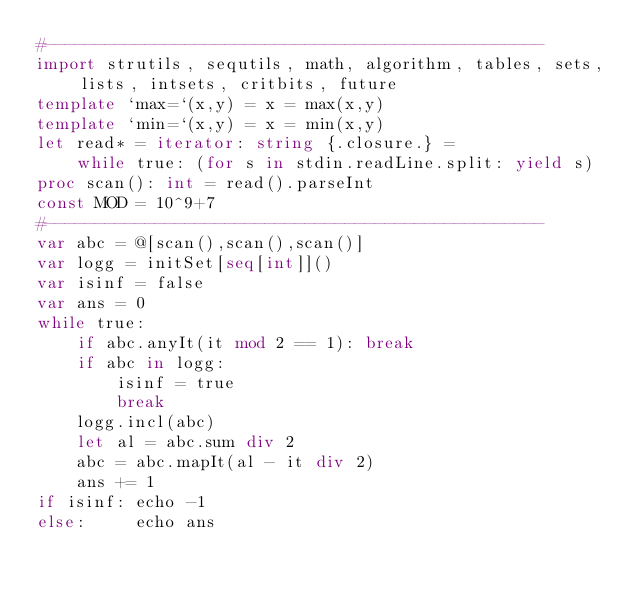Convert code to text. <code><loc_0><loc_0><loc_500><loc_500><_Nim_>#--------------------------------------------------
import strutils, sequtils, math, algorithm, tables, sets, lists, intsets, critbits, future
template `max=`(x,y) = x = max(x,y)
template `min=`(x,y) = x = min(x,y)
let read* = iterator: string {.closure.} =
    while true: (for s in stdin.readLine.split: yield s)
proc scan(): int = read().parseInt
const MOD = 10^9+7
#--------------------------------------------------
var abc = @[scan(),scan(),scan()]
var logg = initSet[seq[int]]()
var isinf = false
var ans = 0
while true:
    if abc.anyIt(it mod 2 == 1): break
    if abc in logg:
        isinf = true
        break
    logg.incl(abc)
    let al = abc.sum div 2
    abc = abc.mapIt(al - it div 2)
    ans += 1
if isinf: echo -1
else:     echo ans</code> 